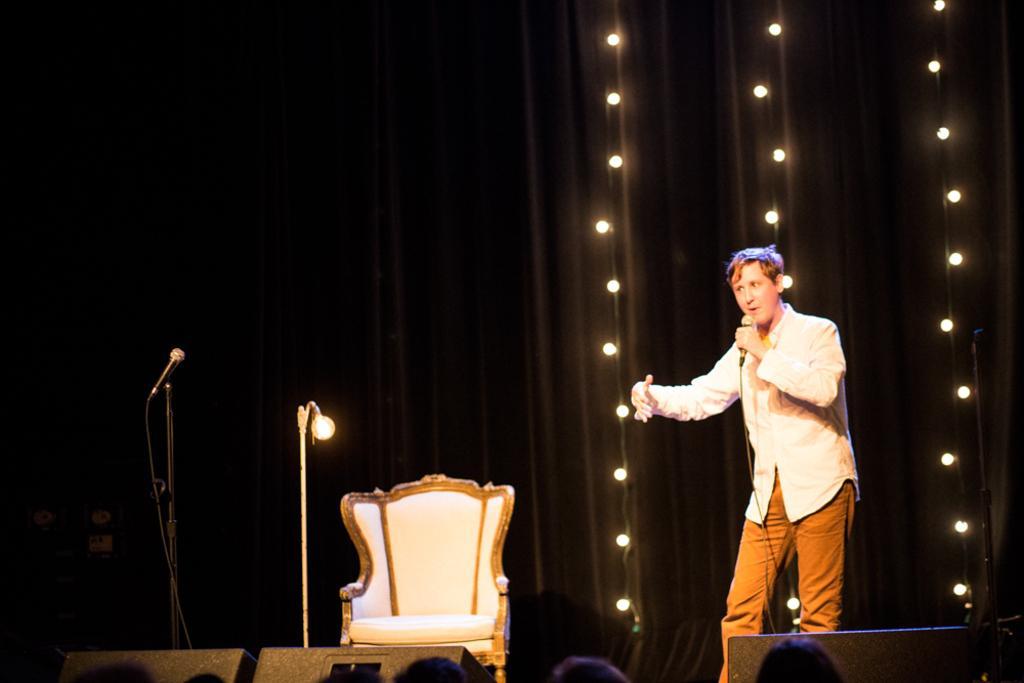Describe this image in one or two sentences. In this image I see a man who is standing and he is holding a mic, I can also see a chair and a mic over here. In the background I see the lights. 